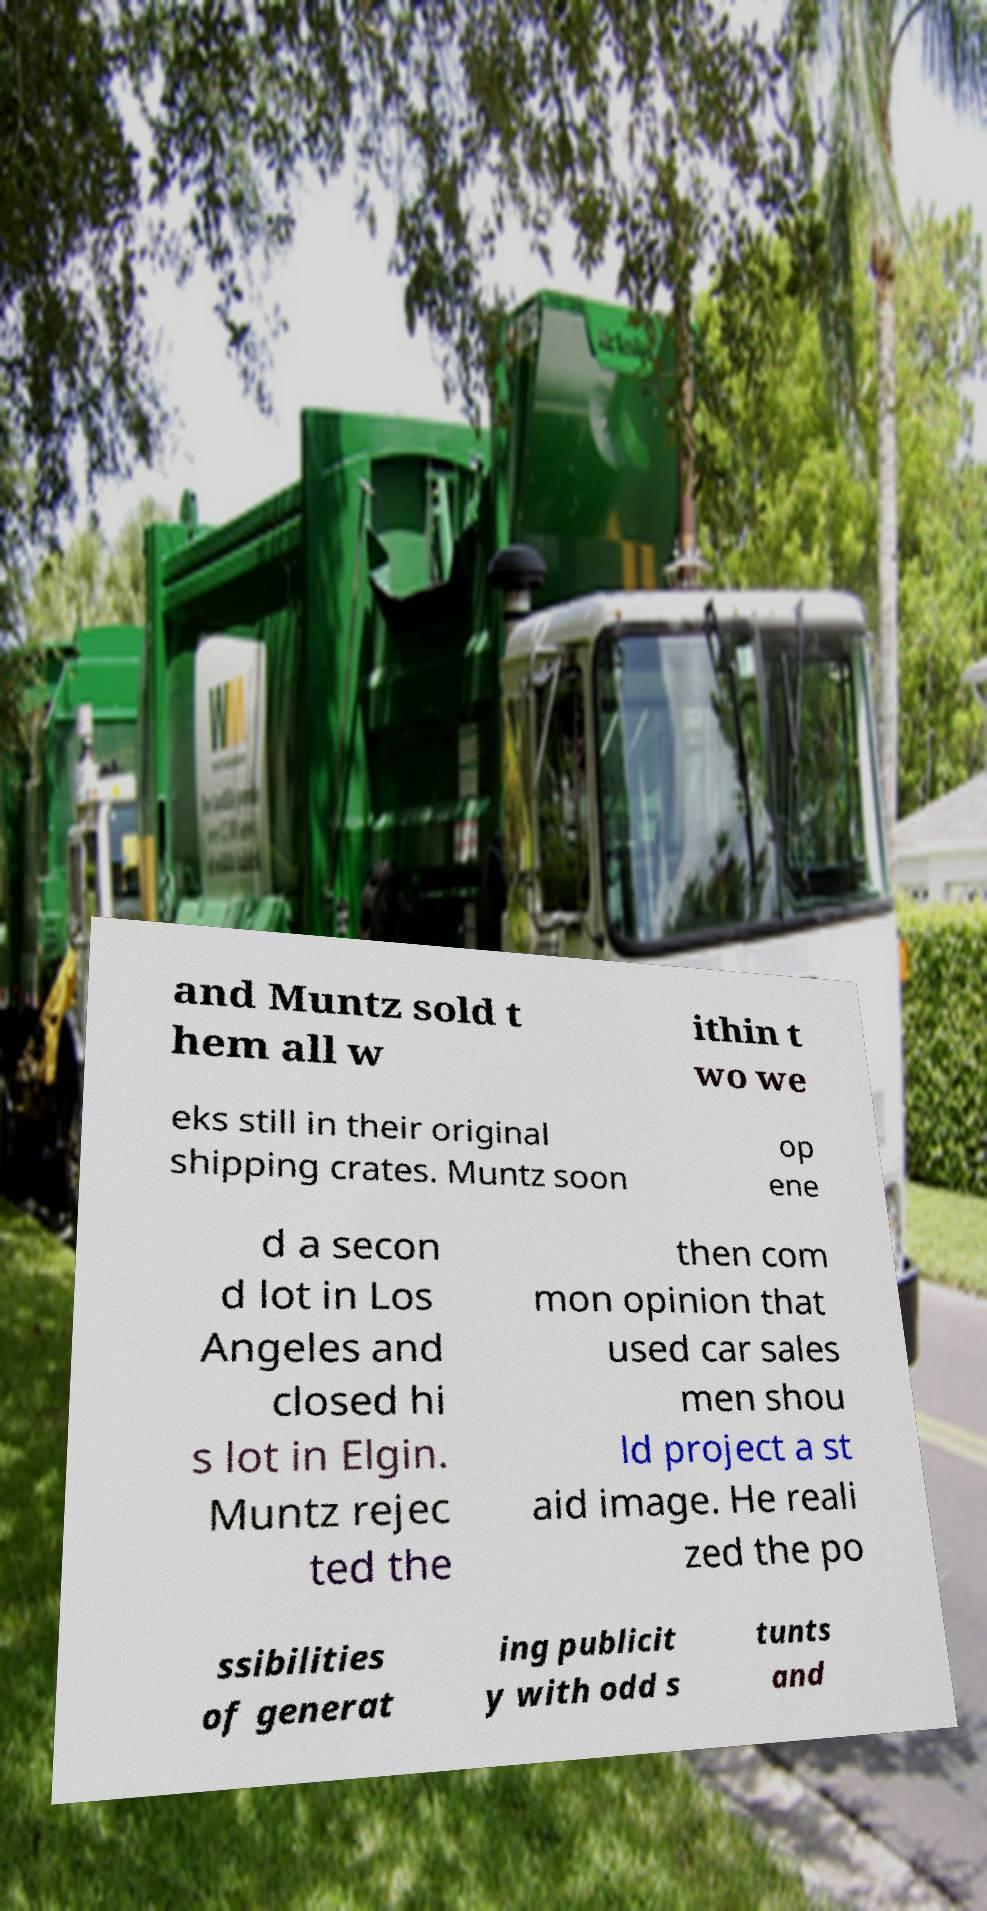There's text embedded in this image that I need extracted. Can you transcribe it verbatim? and Muntz sold t hem all w ithin t wo we eks still in their original shipping crates. Muntz soon op ene d a secon d lot in Los Angeles and closed hi s lot in Elgin. Muntz rejec ted the then com mon opinion that used car sales men shou ld project a st aid image. He reali zed the po ssibilities of generat ing publicit y with odd s tunts and 